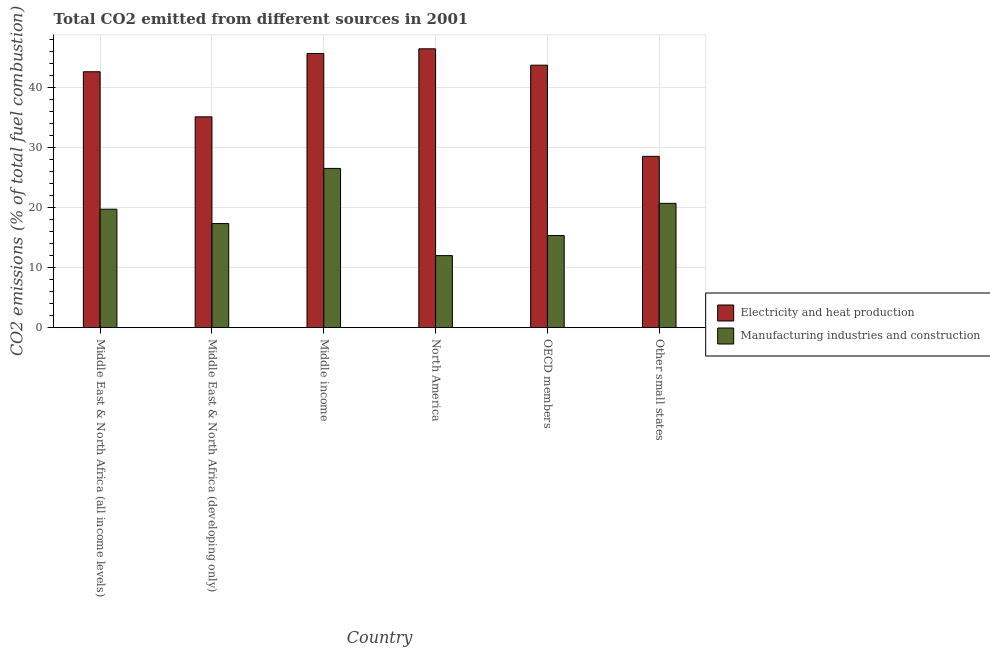How many groups of bars are there?
Offer a terse response. 6. Are the number of bars on each tick of the X-axis equal?
Provide a succinct answer. Yes. How many bars are there on the 1st tick from the left?
Offer a very short reply. 2. In how many cases, is the number of bars for a given country not equal to the number of legend labels?
Your answer should be compact. 0. What is the co2 emissions due to manufacturing industries in Middle East & North Africa (developing only)?
Provide a succinct answer. 17.35. Across all countries, what is the maximum co2 emissions due to manufacturing industries?
Offer a very short reply. 26.53. Across all countries, what is the minimum co2 emissions due to manufacturing industries?
Your response must be concise. 12.01. In which country was the co2 emissions due to electricity and heat production minimum?
Give a very brief answer. Other small states. What is the total co2 emissions due to manufacturing industries in the graph?
Your answer should be compact. 111.7. What is the difference between the co2 emissions due to manufacturing industries in OECD members and that in Other small states?
Keep it short and to the point. -5.35. What is the difference between the co2 emissions due to manufacturing industries in Middle income and the co2 emissions due to electricity and heat production in Middle East & North Africa (developing only)?
Provide a succinct answer. -8.59. What is the average co2 emissions due to electricity and heat production per country?
Provide a succinct answer. 40.36. What is the difference between the co2 emissions due to electricity and heat production and co2 emissions due to manufacturing industries in Middle East & North Africa (developing only)?
Make the answer very short. 17.78. In how many countries, is the co2 emissions due to electricity and heat production greater than 6 %?
Provide a succinct answer. 6. What is the ratio of the co2 emissions due to manufacturing industries in Middle East & North Africa (all income levels) to that in Middle income?
Provide a succinct answer. 0.74. Is the co2 emissions due to manufacturing industries in North America less than that in OECD members?
Provide a succinct answer. Yes. Is the difference between the co2 emissions due to electricity and heat production in Middle East & North Africa (all income levels) and Middle East & North Africa (developing only) greater than the difference between the co2 emissions due to manufacturing industries in Middle East & North Africa (all income levels) and Middle East & North Africa (developing only)?
Keep it short and to the point. Yes. What is the difference between the highest and the second highest co2 emissions due to electricity and heat production?
Keep it short and to the point. 0.78. What is the difference between the highest and the lowest co2 emissions due to electricity and heat production?
Offer a very short reply. 17.92. What does the 1st bar from the left in North America represents?
Give a very brief answer. Electricity and heat production. What does the 2nd bar from the right in Middle income represents?
Ensure brevity in your answer.  Electricity and heat production. How many bars are there?
Ensure brevity in your answer.  12. Are all the bars in the graph horizontal?
Your response must be concise. No. How many countries are there in the graph?
Provide a short and direct response. 6. Does the graph contain grids?
Offer a very short reply. Yes. How are the legend labels stacked?
Provide a short and direct response. Vertical. What is the title of the graph?
Make the answer very short. Total CO2 emitted from different sources in 2001. Does "Quasi money growth" appear as one of the legend labels in the graph?
Offer a terse response. No. What is the label or title of the X-axis?
Offer a very short reply. Country. What is the label or title of the Y-axis?
Your answer should be very brief. CO2 emissions (% of total fuel combustion). What is the CO2 emissions (% of total fuel combustion) in Electricity and heat production in Middle East & North Africa (all income levels)?
Your answer should be very brief. 42.64. What is the CO2 emissions (% of total fuel combustion) in Manufacturing industries and construction in Middle East & North Africa (all income levels)?
Give a very brief answer. 19.74. What is the CO2 emissions (% of total fuel combustion) in Electricity and heat production in Middle East & North Africa (developing only)?
Offer a very short reply. 35.13. What is the CO2 emissions (% of total fuel combustion) of Manufacturing industries and construction in Middle East & North Africa (developing only)?
Your response must be concise. 17.35. What is the CO2 emissions (% of total fuel combustion) of Electricity and heat production in Middle income?
Your response must be concise. 45.69. What is the CO2 emissions (% of total fuel combustion) of Manufacturing industries and construction in Middle income?
Your answer should be compact. 26.53. What is the CO2 emissions (% of total fuel combustion) of Electricity and heat production in North America?
Your answer should be compact. 46.46. What is the CO2 emissions (% of total fuel combustion) in Manufacturing industries and construction in North America?
Your answer should be compact. 12.01. What is the CO2 emissions (% of total fuel combustion) in Electricity and heat production in OECD members?
Your response must be concise. 43.73. What is the CO2 emissions (% of total fuel combustion) of Manufacturing industries and construction in OECD members?
Keep it short and to the point. 15.36. What is the CO2 emissions (% of total fuel combustion) of Electricity and heat production in Other small states?
Give a very brief answer. 28.54. What is the CO2 emissions (% of total fuel combustion) in Manufacturing industries and construction in Other small states?
Give a very brief answer. 20.71. Across all countries, what is the maximum CO2 emissions (% of total fuel combustion) in Electricity and heat production?
Your answer should be very brief. 46.46. Across all countries, what is the maximum CO2 emissions (% of total fuel combustion) of Manufacturing industries and construction?
Provide a short and direct response. 26.53. Across all countries, what is the minimum CO2 emissions (% of total fuel combustion) of Electricity and heat production?
Your response must be concise. 28.54. Across all countries, what is the minimum CO2 emissions (% of total fuel combustion) in Manufacturing industries and construction?
Provide a short and direct response. 12.01. What is the total CO2 emissions (% of total fuel combustion) of Electricity and heat production in the graph?
Offer a very short reply. 242.19. What is the total CO2 emissions (% of total fuel combustion) of Manufacturing industries and construction in the graph?
Your response must be concise. 111.7. What is the difference between the CO2 emissions (% of total fuel combustion) of Electricity and heat production in Middle East & North Africa (all income levels) and that in Middle East & North Africa (developing only)?
Your response must be concise. 7.51. What is the difference between the CO2 emissions (% of total fuel combustion) in Manufacturing industries and construction in Middle East & North Africa (all income levels) and that in Middle East & North Africa (developing only)?
Ensure brevity in your answer.  2.39. What is the difference between the CO2 emissions (% of total fuel combustion) of Electricity and heat production in Middle East & North Africa (all income levels) and that in Middle income?
Provide a succinct answer. -3.05. What is the difference between the CO2 emissions (% of total fuel combustion) in Manufacturing industries and construction in Middle East & North Africa (all income levels) and that in Middle income?
Offer a terse response. -6.8. What is the difference between the CO2 emissions (% of total fuel combustion) of Electricity and heat production in Middle East & North Africa (all income levels) and that in North America?
Keep it short and to the point. -3.82. What is the difference between the CO2 emissions (% of total fuel combustion) in Manufacturing industries and construction in Middle East & North Africa (all income levels) and that in North America?
Offer a very short reply. 7.73. What is the difference between the CO2 emissions (% of total fuel combustion) in Electricity and heat production in Middle East & North Africa (all income levels) and that in OECD members?
Keep it short and to the point. -1.1. What is the difference between the CO2 emissions (% of total fuel combustion) in Manufacturing industries and construction in Middle East & North Africa (all income levels) and that in OECD members?
Offer a very short reply. 4.38. What is the difference between the CO2 emissions (% of total fuel combustion) of Electricity and heat production in Middle East & North Africa (all income levels) and that in Other small states?
Your response must be concise. 14.1. What is the difference between the CO2 emissions (% of total fuel combustion) in Manufacturing industries and construction in Middle East & North Africa (all income levels) and that in Other small states?
Offer a terse response. -0.98. What is the difference between the CO2 emissions (% of total fuel combustion) in Electricity and heat production in Middle East & North Africa (developing only) and that in Middle income?
Offer a terse response. -10.56. What is the difference between the CO2 emissions (% of total fuel combustion) of Manufacturing industries and construction in Middle East & North Africa (developing only) and that in Middle income?
Provide a short and direct response. -9.19. What is the difference between the CO2 emissions (% of total fuel combustion) of Electricity and heat production in Middle East & North Africa (developing only) and that in North America?
Provide a succinct answer. -11.33. What is the difference between the CO2 emissions (% of total fuel combustion) of Manufacturing industries and construction in Middle East & North Africa (developing only) and that in North America?
Your answer should be very brief. 5.34. What is the difference between the CO2 emissions (% of total fuel combustion) of Electricity and heat production in Middle East & North Africa (developing only) and that in OECD members?
Ensure brevity in your answer.  -8.61. What is the difference between the CO2 emissions (% of total fuel combustion) of Manufacturing industries and construction in Middle East & North Africa (developing only) and that in OECD members?
Provide a short and direct response. 1.99. What is the difference between the CO2 emissions (% of total fuel combustion) in Electricity and heat production in Middle East & North Africa (developing only) and that in Other small states?
Your answer should be very brief. 6.58. What is the difference between the CO2 emissions (% of total fuel combustion) of Manufacturing industries and construction in Middle East & North Africa (developing only) and that in Other small states?
Give a very brief answer. -3.37. What is the difference between the CO2 emissions (% of total fuel combustion) in Electricity and heat production in Middle income and that in North America?
Provide a succinct answer. -0.78. What is the difference between the CO2 emissions (% of total fuel combustion) of Manufacturing industries and construction in Middle income and that in North America?
Your response must be concise. 14.53. What is the difference between the CO2 emissions (% of total fuel combustion) in Electricity and heat production in Middle income and that in OECD members?
Your answer should be very brief. 1.95. What is the difference between the CO2 emissions (% of total fuel combustion) in Manufacturing industries and construction in Middle income and that in OECD members?
Provide a short and direct response. 11.18. What is the difference between the CO2 emissions (% of total fuel combustion) in Electricity and heat production in Middle income and that in Other small states?
Provide a succinct answer. 17.14. What is the difference between the CO2 emissions (% of total fuel combustion) of Manufacturing industries and construction in Middle income and that in Other small states?
Keep it short and to the point. 5.82. What is the difference between the CO2 emissions (% of total fuel combustion) in Electricity and heat production in North America and that in OECD members?
Provide a short and direct response. 2.73. What is the difference between the CO2 emissions (% of total fuel combustion) in Manufacturing industries and construction in North America and that in OECD members?
Your answer should be very brief. -3.35. What is the difference between the CO2 emissions (% of total fuel combustion) of Electricity and heat production in North America and that in Other small states?
Offer a very short reply. 17.92. What is the difference between the CO2 emissions (% of total fuel combustion) in Manufacturing industries and construction in North America and that in Other small states?
Your answer should be compact. -8.71. What is the difference between the CO2 emissions (% of total fuel combustion) of Electricity and heat production in OECD members and that in Other small states?
Make the answer very short. 15.19. What is the difference between the CO2 emissions (% of total fuel combustion) in Manufacturing industries and construction in OECD members and that in Other small states?
Keep it short and to the point. -5.35. What is the difference between the CO2 emissions (% of total fuel combustion) of Electricity and heat production in Middle East & North Africa (all income levels) and the CO2 emissions (% of total fuel combustion) of Manufacturing industries and construction in Middle East & North Africa (developing only)?
Offer a terse response. 25.29. What is the difference between the CO2 emissions (% of total fuel combustion) in Electricity and heat production in Middle East & North Africa (all income levels) and the CO2 emissions (% of total fuel combustion) in Manufacturing industries and construction in Middle income?
Provide a short and direct response. 16.1. What is the difference between the CO2 emissions (% of total fuel combustion) in Electricity and heat production in Middle East & North Africa (all income levels) and the CO2 emissions (% of total fuel combustion) in Manufacturing industries and construction in North America?
Provide a succinct answer. 30.63. What is the difference between the CO2 emissions (% of total fuel combustion) in Electricity and heat production in Middle East & North Africa (all income levels) and the CO2 emissions (% of total fuel combustion) in Manufacturing industries and construction in OECD members?
Give a very brief answer. 27.28. What is the difference between the CO2 emissions (% of total fuel combustion) in Electricity and heat production in Middle East & North Africa (all income levels) and the CO2 emissions (% of total fuel combustion) in Manufacturing industries and construction in Other small states?
Your response must be concise. 21.92. What is the difference between the CO2 emissions (% of total fuel combustion) in Electricity and heat production in Middle East & North Africa (developing only) and the CO2 emissions (% of total fuel combustion) in Manufacturing industries and construction in Middle income?
Your answer should be very brief. 8.59. What is the difference between the CO2 emissions (% of total fuel combustion) of Electricity and heat production in Middle East & North Africa (developing only) and the CO2 emissions (% of total fuel combustion) of Manufacturing industries and construction in North America?
Ensure brevity in your answer.  23.12. What is the difference between the CO2 emissions (% of total fuel combustion) in Electricity and heat production in Middle East & North Africa (developing only) and the CO2 emissions (% of total fuel combustion) in Manufacturing industries and construction in OECD members?
Offer a terse response. 19.77. What is the difference between the CO2 emissions (% of total fuel combustion) in Electricity and heat production in Middle East & North Africa (developing only) and the CO2 emissions (% of total fuel combustion) in Manufacturing industries and construction in Other small states?
Offer a very short reply. 14.41. What is the difference between the CO2 emissions (% of total fuel combustion) of Electricity and heat production in Middle income and the CO2 emissions (% of total fuel combustion) of Manufacturing industries and construction in North America?
Provide a succinct answer. 33.68. What is the difference between the CO2 emissions (% of total fuel combustion) in Electricity and heat production in Middle income and the CO2 emissions (% of total fuel combustion) in Manufacturing industries and construction in OECD members?
Keep it short and to the point. 30.33. What is the difference between the CO2 emissions (% of total fuel combustion) of Electricity and heat production in Middle income and the CO2 emissions (% of total fuel combustion) of Manufacturing industries and construction in Other small states?
Offer a terse response. 24.97. What is the difference between the CO2 emissions (% of total fuel combustion) of Electricity and heat production in North America and the CO2 emissions (% of total fuel combustion) of Manufacturing industries and construction in OECD members?
Offer a terse response. 31.1. What is the difference between the CO2 emissions (% of total fuel combustion) in Electricity and heat production in North America and the CO2 emissions (% of total fuel combustion) in Manufacturing industries and construction in Other small states?
Your response must be concise. 25.75. What is the difference between the CO2 emissions (% of total fuel combustion) of Electricity and heat production in OECD members and the CO2 emissions (% of total fuel combustion) of Manufacturing industries and construction in Other small states?
Provide a succinct answer. 23.02. What is the average CO2 emissions (% of total fuel combustion) of Electricity and heat production per country?
Ensure brevity in your answer.  40.37. What is the average CO2 emissions (% of total fuel combustion) of Manufacturing industries and construction per country?
Make the answer very short. 18.62. What is the difference between the CO2 emissions (% of total fuel combustion) of Electricity and heat production and CO2 emissions (% of total fuel combustion) of Manufacturing industries and construction in Middle East & North Africa (all income levels)?
Your answer should be very brief. 22.9. What is the difference between the CO2 emissions (% of total fuel combustion) in Electricity and heat production and CO2 emissions (% of total fuel combustion) in Manufacturing industries and construction in Middle East & North Africa (developing only)?
Offer a very short reply. 17.78. What is the difference between the CO2 emissions (% of total fuel combustion) of Electricity and heat production and CO2 emissions (% of total fuel combustion) of Manufacturing industries and construction in Middle income?
Make the answer very short. 19.15. What is the difference between the CO2 emissions (% of total fuel combustion) of Electricity and heat production and CO2 emissions (% of total fuel combustion) of Manufacturing industries and construction in North America?
Your answer should be very brief. 34.46. What is the difference between the CO2 emissions (% of total fuel combustion) in Electricity and heat production and CO2 emissions (% of total fuel combustion) in Manufacturing industries and construction in OECD members?
Ensure brevity in your answer.  28.38. What is the difference between the CO2 emissions (% of total fuel combustion) of Electricity and heat production and CO2 emissions (% of total fuel combustion) of Manufacturing industries and construction in Other small states?
Provide a succinct answer. 7.83. What is the ratio of the CO2 emissions (% of total fuel combustion) in Electricity and heat production in Middle East & North Africa (all income levels) to that in Middle East & North Africa (developing only)?
Keep it short and to the point. 1.21. What is the ratio of the CO2 emissions (% of total fuel combustion) of Manufacturing industries and construction in Middle East & North Africa (all income levels) to that in Middle East & North Africa (developing only)?
Give a very brief answer. 1.14. What is the ratio of the CO2 emissions (% of total fuel combustion) of Electricity and heat production in Middle East & North Africa (all income levels) to that in Middle income?
Ensure brevity in your answer.  0.93. What is the ratio of the CO2 emissions (% of total fuel combustion) in Manufacturing industries and construction in Middle East & North Africa (all income levels) to that in Middle income?
Make the answer very short. 0.74. What is the ratio of the CO2 emissions (% of total fuel combustion) of Electricity and heat production in Middle East & North Africa (all income levels) to that in North America?
Keep it short and to the point. 0.92. What is the ratio of the CO2 emissions (% of total fuel combustion) of Manufacturing industries and construction in Middle East & North Africa (all income levels) to that in North America?
Provide a short and direct response. 1.64. What is the ratio of the CO2 emissions (% of total fuel combustion) of Electricity and heat production in Middle East & North Africa (all income levels) to that in OECD members?
Your response must be concise. 0.97. What is the ratio of the CO2 emissions (% of total fuel combustion) in Manufacturing industries and construction in Middle East & North Africa (all income levels) to that in OECD members?
Offer a very short reply. 1.29. What is the ratio of the CO2 emissions (% of total fuel combustion) in Electricity and heat production in Middle East & North Africa (all income levels) to that in Other small states?
Make the answer very short. 1.49. What is the ratio of the CO2 emissions (% of total fuel combustion) of Manufacturing industries and construction in Middle East & North Africa (all income levels) to that in Other small states?
Provide a succinct answer. 0.95. What is the ratio of the CO2 emissions (% of total fuel combustion) of Electricity and heat production in Middle East & North Africa (developing only) to that in Middle income?
Your answer should be compact. 0.77. What is the ratio of the CO2 emissions (% of total fuel combustion) of Manufacturing industries and construction in Middle East & North Africa (developing only) to that in Middle income?
Provide a short and direct response. 0.65. What is the ratio of the CO2 emissions (% of total fuel combustion) in Electricity and heat production in Middle East & North Africa (developing only) to that in North America?
Give a very brief answer. 0.76. What is the ratio of the CO2 emissions (% of total fuel combustion) in Manufacturing industries and construction in Middle East & North Africa (developing only) to that in North America?
Give a very brief answer. 1.45. What is the ratio of the CO2 emissions (% of total fuel combustion) in Electricity and heat production in Middle East & North Africa (developing only) to that in OECD members?
Your answer should be very brief. 0.8. What is the ratio of the CO2 emissions (% of total fuel combustion) of Manufacturing industries and construction in Middle East & North Africa (developing only) to that in OECD members?
Make the answer very short. 1.13. What is the ratio of the CO2 emissions (% of total fuel combustion) in Electricity and heat production in Middle East & North Africa (developing only) to that in Other small states?
Your response must be concise. 1.23. What is the ratio of the CO2 emissions (% of total fuel combustion) in Manufacturing industries and construction in Middle East & North Africa (developing only) to that in Other small states?
Your answer should be compact. 0.84. What is the ratio of the CO2 emissions (% of total fuel combustion) in Electricity and heat production in Middle income to that in North America?
Provide a short and direct response. 0.98. What is the ratio of the CO2 emissions (% of total fuel combustion) of Manufacturing industries and construction in Middle income to that in North America?
Provide a short and direct response. 2.21. What is the ratio of the CO2 emissions (% of total fuel combustion) of Electricity and heat production in Middle income to that in OECD members?
Keep it short and to the point. 1.04. What is the ratio of the CO2 emissions (% of total fuel combustion) of Manufacturing industries and construction in Middle income to that in OECD members?
Make the answer very short. 1.73. What is the ratio of the CO2 emissions (% of total fuel combustion) of Electricity and heat production in Middle income to that in Other small states?
Your answer should be very brief. 1.6. What is the ratio of the CO2 emissions (% of total fuel combustion) in Manufacturing industries and construction in Middle income to that in Other small states?
Your answer should be very brief. 1.28. What is the ratio of the CO2 emissions (% of total fuel combustion) in Electricity and heat production in North America to that in OECD members?
Your answer should be very brief. 1.06. What is the ratio of the CO2 emissions (% of total fuel combustion) of Manufacturing industries and construction in North America to that in OECD members?
Offer a very short reply. 0.78. What is the ratio of the CO2 emissions (% of total fuel combustion) in Electricity and heat production in North America to that in Other small states?
Your response must be concise. 1.63. What is the ratio of the CO2 emissions (% of total fuel combustion) of Manufacturing industries and construction in North America to that in Other small states?
Make the answer very short. 0.58. What is the ratio of the CO2 emissions (% of total fuel combustion) in Electricity and heat production in OECD members to that in Other small states?
Your answer should be compact. 1.53. What is the ratio of the CO2 emissions (% of total fuel combustion) of Manufacturing industries and construction in OECD members to that in Other small states?
Offer a terse response. 0.74. What is the difference between the highest and the second highest CO2 emissions (% of total fuel combustion) in Electricity and heat production?
Offer a very short reply. 0.78. What is the difference between the highest and the second highest CO2 emissions (% of total fuel combustion) in Manufacturing industries and construction?
Offer a terse response. 5.82. What is the difference between the highest and the lowest CO2 emissions (% of total fuel combustion) in Electricity and heat production?
Offer a terse response. 17.92. What is the difference between the highest and the lowest CO2 emissions (% of total fuel combustion) of Manufacturing industries and construction?
Your response must be concise. 14.53. 